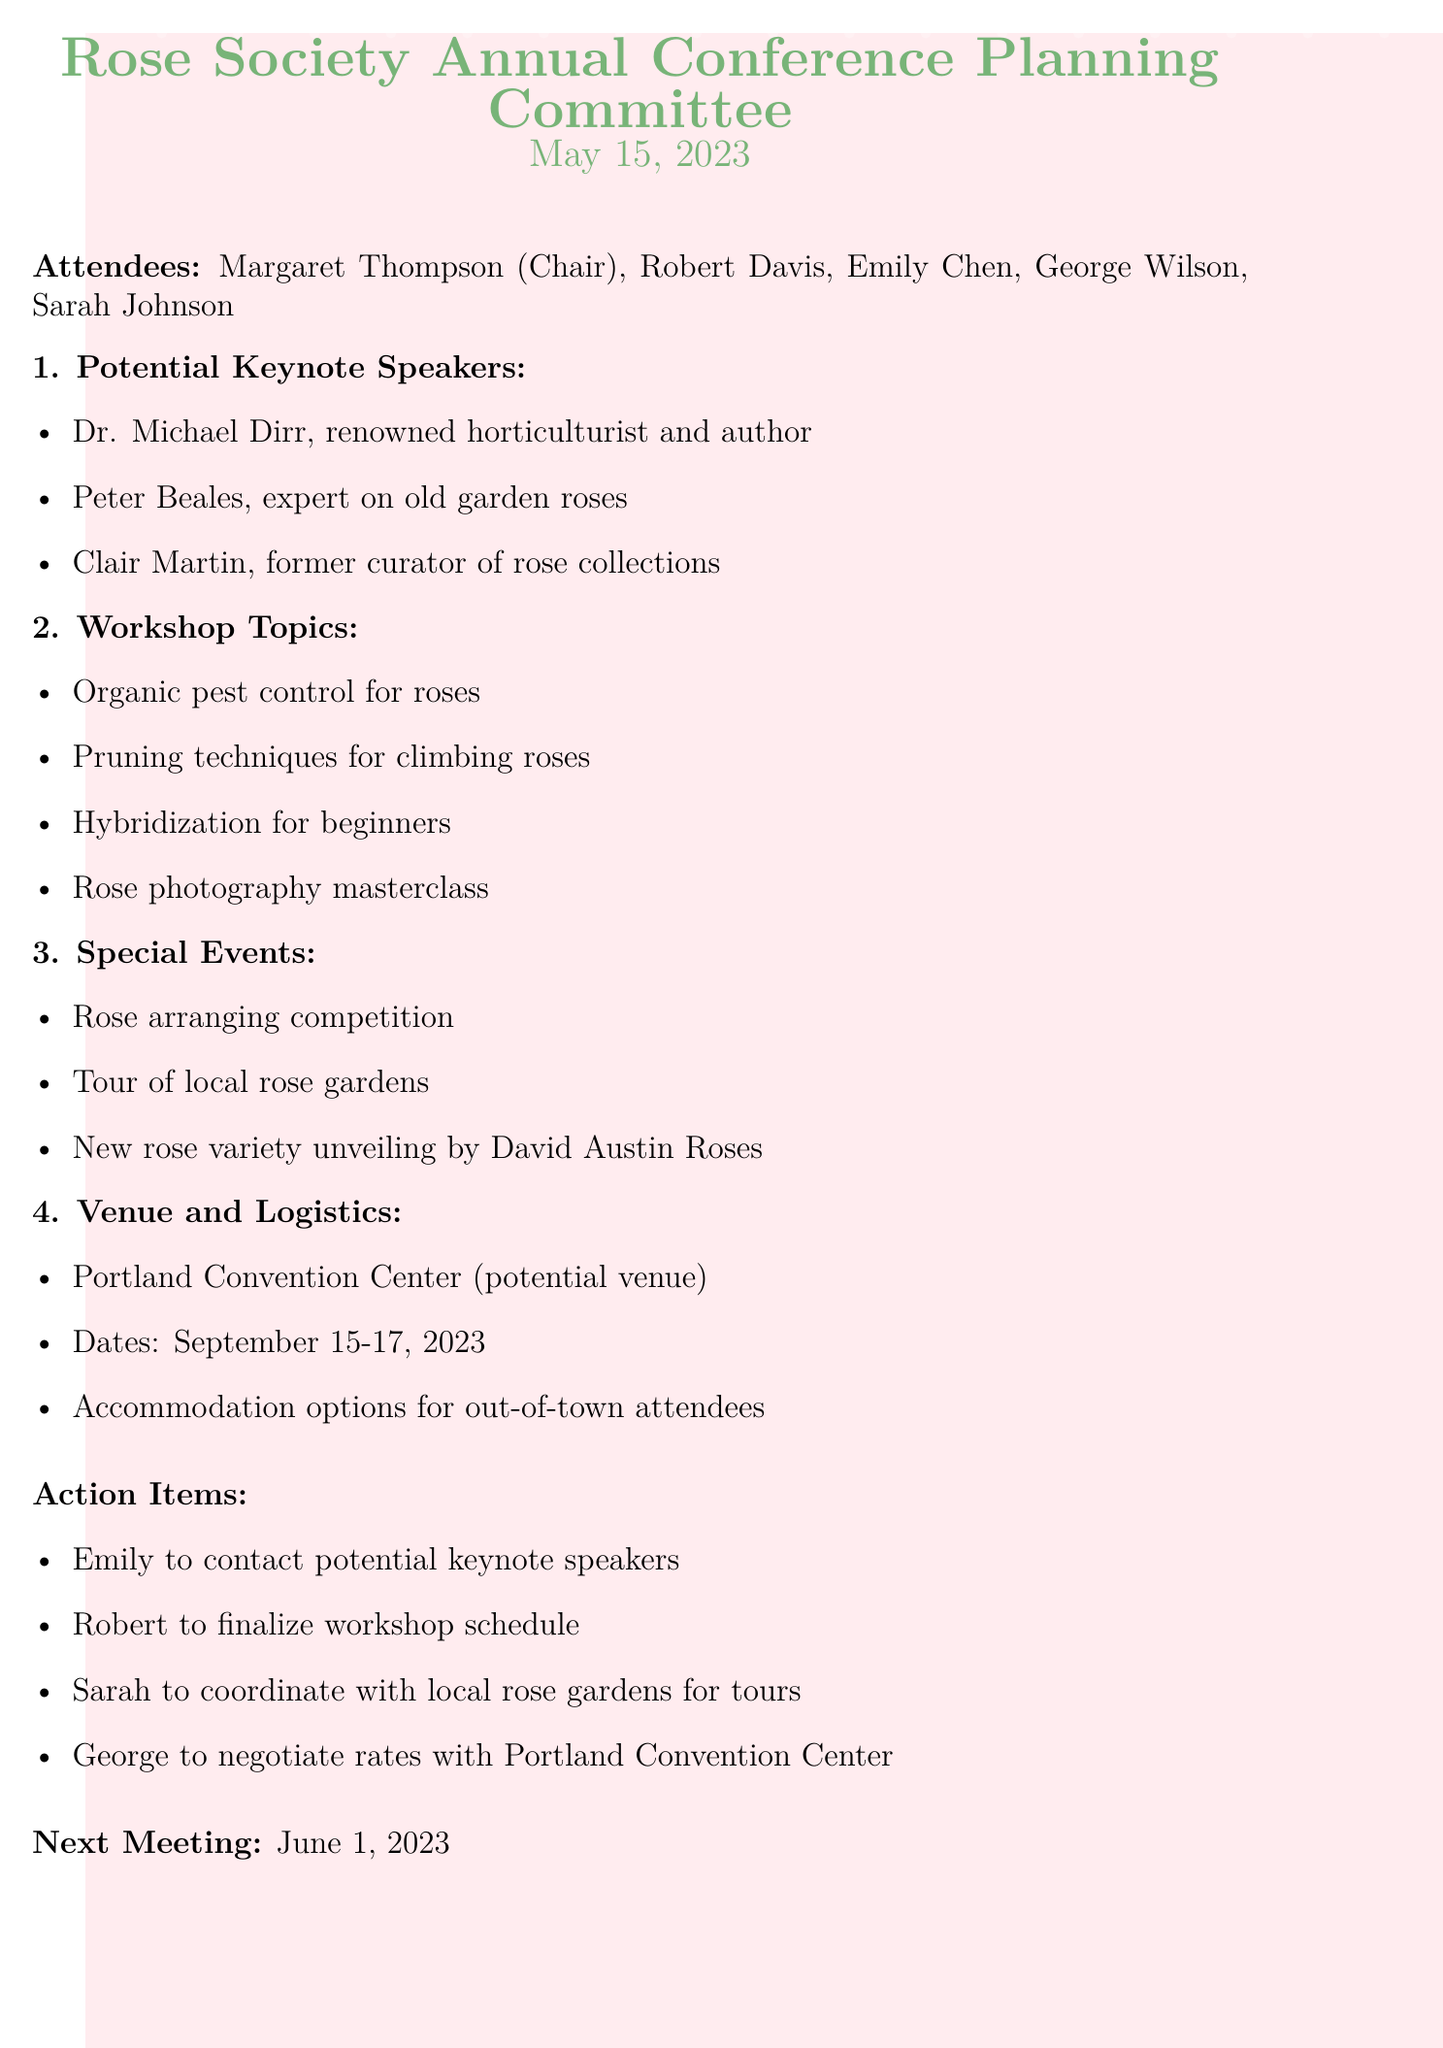What is the date of the meeting? The date of the meeting is clearly stated at the beginning of the document.
Answer: May 15, 2023 Who is the chair of the meeting? The document lists attendees and specifies who the chair is.
Answer: Margaret Thompson What are the proposed dates for the conference? The document outlines the dates discussed for the event.
Answer: September 15-17, 2023 Which speaker is an expert on old garden roses? The document provides a list of potential keynote speakers and their specialties.
Answer: Peter Beales What workshop topic focuses on climbing roses? Workshop topics are discussed in the agenda, specifying the focus of each.
Answer: Pruning techniques for climbing roses How many action items were mentioned during the meeting? By counting the items in the action list, we can find the total number.
Answer: Four What event features a competition related to rose arrangements? The document mentions a special event that includes a competition for rose arrangements.
Answer: Rose arranging competition When is the next meeting scheduled? The document mentions the next meeting date toward the end.
Answer: June 1, 2023 